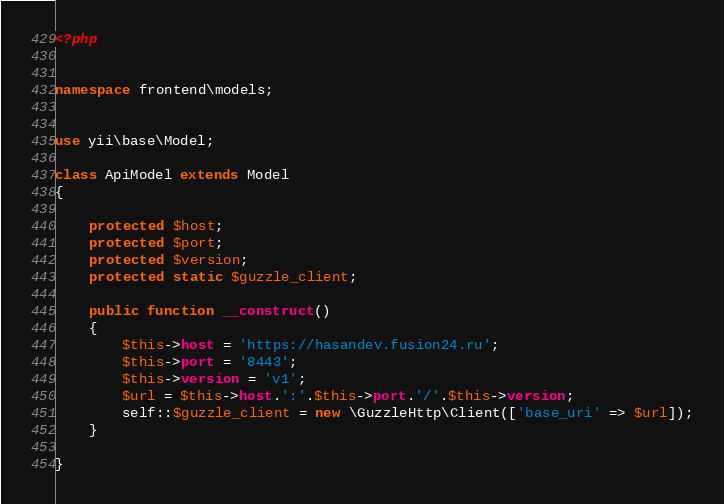<code> <loc_0><loc_0><loc_500><loc_500><_PHP_><?php


namespace frontend\models;


use yii\base\Model;

class ApiModel extends Model
{

    protected $host;
    protected $port;
    protected $version;
    protected static $guzzle_client;

    public function __construct()
    {
        $this->host = 'https://hasandev.fusion24.ru';
        $this->port = '8443';
        $this->version = 'v1';
        $url = $this->host.':'.$this->port.'/'.$this->version;
        self::$guzzle_client = new \GuzzleHttp\Client(['base_uri' => $url]);
    }

}</code> 